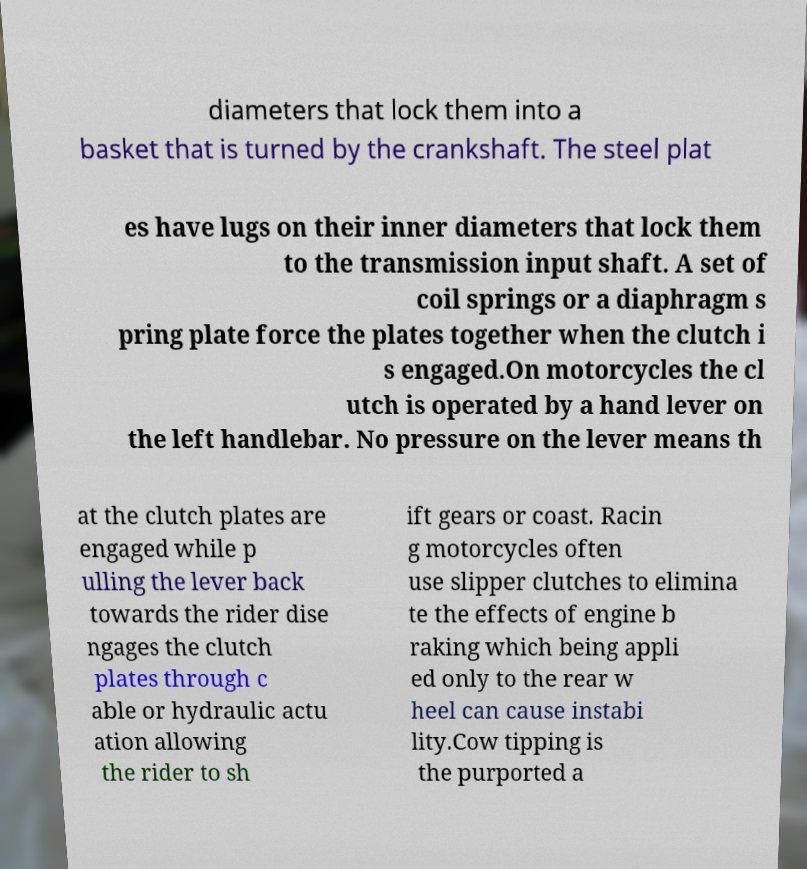Could you extract and type out the text from this image? diameters that lock them into a basket that is turned by the crankshaft. The steel plat es have lugs on their inner diameters that lock them to the transmission input shaft. A set of coil springs or a diaphragm s pring plate force the plates together when the clutch i s engaged.On motorcycles the cl utch is operated by a hand lever on the left handlebar. No pressure on the lever means th at the clutch plates are engaged while p ulling the lever back towards the rider dise ngages the clutch plates through c able or hydraulic actu ation allowing the rider to sh ift gears or coast. Racin g motorcycles often use slipper clutches to elimina te the effects of engine b raking which being appli ed only to the rear w heel can cause instabi lity.Cow tipping is the purported a 